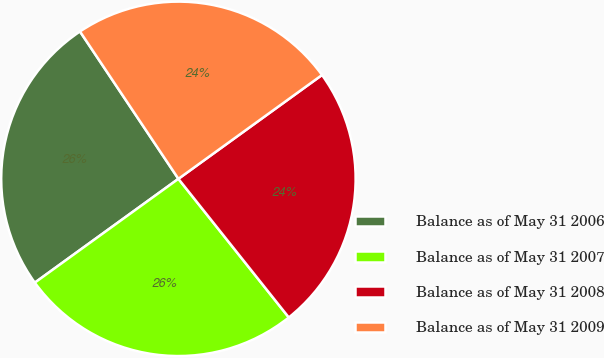<chart> <loc_0><loc_0><loc_500><loc_500><pie_chart><fcel>Balance as of May 31 2006<fcel>Balance as of May 31 2007<fcel>Balance as of May 31 2008<fcel>Balance as of May 31 2009<nl><fcel>25.59%<fcel>25.74%<fcel>24.26%<fcel>24.41%<nl></chart> 